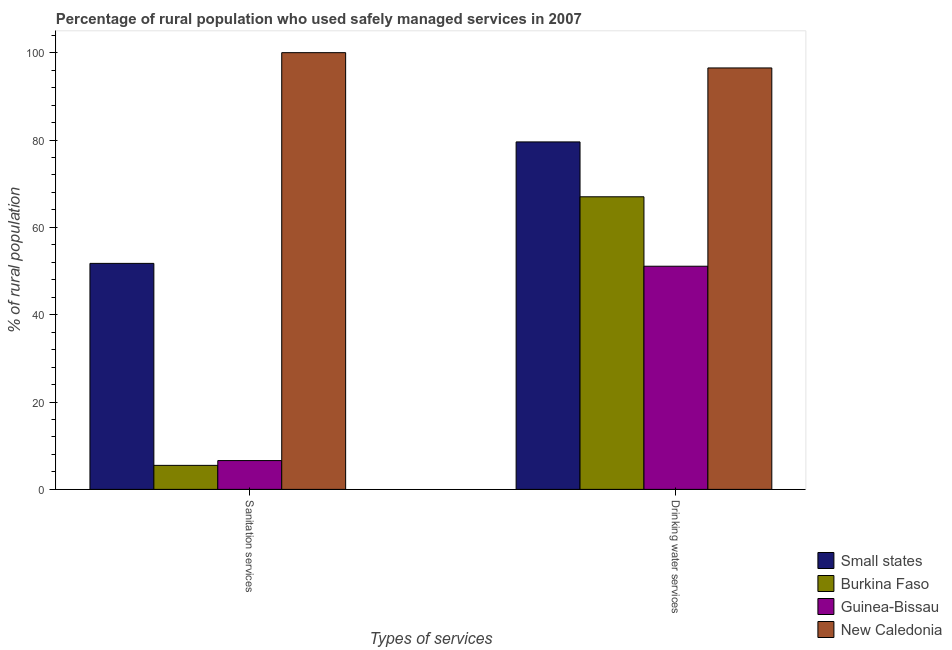How many different coloured bars are there?
Make the answer very short. 4. How many groups of bars are there?
Offer a very short reply. 2. What is the label of the 1st group of bars from the left?
Offer a terse response. Sanitation services. What is the percentage of rural population who used sanitation services in Guinea-Bissau?
Provide a short and direct response. 6.6. Across all countries, what is the maximum percentage of rural population who used drinking water services?
Your answer should be compact. 96.5. In which country was the percentage of rural population who used drinking water services maximum?
Give a very brief answer. New Caledonia. In which country was the percentage of rural population who used drinking water services minimum?
Your response must be concise. Guinea-Bissau. What is the total percentage of rural population who used sanitation services in the graph?
Offer a terse response. 163.85. What is the difference between the percentage of rural population who used sanitation services in Guinea-Bissau and that in New Caledonia?
Offer a very short reply. -93.4. What is the difference between the percentage of rural population who used drinking water services in Small states and the percentage of rural population who used sanitation services in Guinea-Bissau?
Your answer should be very brief. 72.96. What is the average percentage of rural population who used drinking water services per country?
Provide a succinct answer. 73.54. What is the difference between the percentage of rural population who used drinking water services and percentage of rural population who used sanitation services in Burkina Faso?
Your answer should be very brief. 61.5. In how many countries, is the percentage of rural population who used sanitation services greater than 40 %?
Offer a very short reply. 2. What is the ratio of the percentage of rural population who used drinking water services in New Caledonia to that in Small states?
Keep it short and to the point. 1.21. Is the percentage of rural population who used sanitation services in New Caledonia less than that in Guinea-Bissau?
Make the answer very short. No. In how many countries, is the percentage of rural population who used sanitation services greater than the average percentage of rural population who used sanitation services taken over all countries?
Offer a terse response. 2. What does the 4th bar from the left in Drinking water services represents?
Give a very brief answer. New Caledonia. What does the 1st bar from the right in Sanitation services represents?
Your answer should be compact. New Caledonia. How many bars are there?
Your answer should be compact. 8. Are all the bars in the graph horizontal?
Give a very brief answer. No. What is the difference between two consecutive major ticks on the Y-axis?
Keep it short and to the point. 20. Are the values on the major ticks of Y-axis written in scientific E-notation?
Ensure brevity in your answer.  No. Does the graph contain any zero values?
Provide a succinct answer. No. Does the graph contain grids?
Provide a short and direct response. No. How many legend labels are there?
Offer a very short reply. 4. What is the title of the graph?
Your answer should be compact. Percentage of rural population who used safely managed services in 2007. Does "South Asia" appear as one of the legend labels in the graph?
Keep it short and to the point. No. What is the label or title of the X-axis?
Keep it short and to the point. Types of services. What is the label or title of the Y-axis?
Provide a succinct answer. % of rural population. What is the % of rural population in Small states in Sanitation services?
Ensure brevity in your answer.  51.75. What is the % of rural population in Burkina Faso in Sanitation services?
Offer a terse response. 5.5. What is the % of rural population of Guinea-Bissau in Sanitation services?
Keep it short and to the point. 6.6. What is the % of rural population in New Caledonia in Sanitation services?
Your response must be concise. 100. What is the % of rural population of Small states in Drinking water services?
Your answer should be very brief. 79.56. What is the % of rural population of Burkina Faso in Drinking water services?
Offer a terse response. 67. What is the % of rural population of Guinea-Bissau in Drinking water services?
Your response must be concise. 51.1. What is the % of rural population of New Caledonia in Drinking water services?
Your response must be concise. 96.5. Across all Types of services, what is the maximum % of rural population of Small states?
Provide a succinct answer. 79.56. Across all Types of services, what is the maximum % of rural population of Guinea-Bissau?
Make the answer very short. 51.1. Across all Types of services, what is the maximum % of rural population of New Caledonia?
Your response must be concise. 100. Across all Types of services, what is the minimum % of rural population in Small states?
Offer a very short reply. 51.75. Across all Types of services, what is the minimum % of rural population in New Caledonia?
Your answer should be compact. 96.5. What is the total % of rural population in Small states in the graph?
Keep it short and to the point. 131.31. What is the total % of rural population of Burkina Faso in the graph?
Give a very brief answer. 72.5. What is the total % of rural population in Guinea-Bissau in the graph?
Keep it short and to the point. 57.7. What is the total % of rural population in New Caledonia in the graph?
Your answer should be compact. 196.5. What is the difference between the % of rural population of Small states in Sanitation services and that in Drinking water services?
Provide a short and direct response. -27.81. What is the difference between the % of rural population in Burkina Faso in Sanitation services and that in Drinking water services?
Give a very brief answer. -61.5. What is the difference between the % of rural population of Guinea-Bissau in Sanitation services and that in Drinking water services?
Your response must be concise. -44.5. What is the difference between the % of rural population in Small states in Sanitation services and the % of rural population in Burkina Faso in Drinking water services?
Offer a very short reply. -15.25. What is the difference between the % of rural population in Small states in Sanitation services and the % of rural population in Guinea-Bissau in Drinking water services?
Keep it short and to the point. 0.65. What is the difference between the % of rural population in Small states in Sanitation services and the % of rural population in New Caledonia in Drinking water services?
Your answer should be compact. -44.75. What is the difference between the % of rural population in Burkina Faso in Sanitation services and the % of rural population in Guinea-Bissau in Drinking water services?
Your answer should be very brief. -45.6. What is the difference between the % of rural population in Burkina Faso in Sanitation services and the % of rural population in New Caledonia in Drinking water services?
Provide a short and direct response. -91. What is the difference between the % of rural population of Guinea-Bissau in Sanitation services and the % of rural population of New Caledonia in Drinking water services?
Provide a short and direct response. -89.9. What is the average % of rural population in Small states per Types of services?
Your answer should be very brief. 65.66. What is the average % of rural population in Burkina Faso per Types of services?
Ensure brevity in your answer.  36.25. What is the average % of rural population of Guinea-Bissau per Types of services?
Keep it short and to the point. 28.85. What is the average % of rural population of New Caledonia per Types of services?
Keep it short and to the point. 98.25. What is the difference between the % of rural population of Small states and % of rural population of Burkina Faso in Sanitation services?
Give a very brief answer. 46.25. What is the difference between the % of rural population in Small states and % of rural population in Guinea-Bissau in Sanitation services?
Your answer should be very brief. 45.15. What is the difference between the % of rural population of Small states and % of rural population of New Caledonia in Sanitation services?
Give a very brief answer. -48.25. What is the difference between the % of rural population of Burkina Faso and % of rural population of New Caledonia in Sanitation services?
Make the answer very short. -94.5. What is the difference between the % of rural population of Guinea-Bissau and % of rural population of New Caledonia in Sanitation services?
Provide a short and direct response. -93.4. What is the difference between the % of rural population of Small states and % of rural population of Burkina Faso in Drinking water services?
Your answer should be compact. 12.56. What is the difference between the % of rural population in Small states and % of rural population in Guinea-Bissau in Drinking water services?
Your response must be concise. 28.46. What is the difference between the % of rural population in Small states and % of rural population in New Caledonia in Drinking water services?
Offer a very short reply. -16.94. What is the difference between the % of rural population of Burkina Faso and % of rural population of New Caledonia in Drinking water services?
Keep it short and to the point. -29.5. What is the difference between the % of rural population in Guinea-Bissau and % of rural population in New Caledonia in Drinking water services?
Offer a very short reply. -45.4. What is the ratio of the % of rural population of Small states in Sanitation services to that in Drinking water services?
Offer a very short reply. 0.65. What is the ratio of the % of rural population of Burkina Faso in Sanitation services to that in Drinking water services?
Keep it short and to the point. 0.08. What is the ratio of the % of rural population of Guinea-Bissau in Sanitation services to that in Drinking water services?
Keep it short and to the point. 0.13. What is the ratio of the % of rural population in New Caledonia in Sanitation services to that in Drinking water services?
Your response must be concise. 1.04. What is the difference between the highest and the second highest % of rural population in Small states?
Your answer should be very brief. 27.81. What is the difference between the highest and the second highest % of rural population in Burkina Faso?
Your answer should be very brief. 61.5. What is the difference between the highest and the second highest % of rural population in Guinea-Bissau?
Provide a short and direct response. 44.5. What is the difference between the highest and the lowest % of rural population in Small states?
Give a very brief answer. 27.81. What is the difference between the highest and the lowest % of rural population of Burkina Faso?
Your response must be concise. 61.5. What is the difference between the highest and the lowest % of rural population of Guinea-Bissau?
Offer a very short reply. 44.5. 